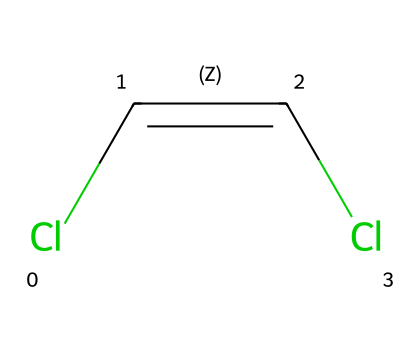What is the molecular formula of this compound? The molecular formula can be determined by counting the number of each type of atom in the structure. Here, there are 2 carbon (C) atoms, 2 chlorine (Cl) atoms, and 2 hydrogen (H) atoms connected in a particular arrangement. Thus, the molecular formula is C2H2Cl2.
Answer: C2H2Cl2 How many double bonds are present in this molecule? The structure shows a double bond between the two carbon atoms as indicated by the 'C=C' part in the SMILES notation. Therefore, there is one double bond present.
Answer: 1 What type of isomerism does dichloroethene exhibit? Dichloroethene exhibits geometric isomerism because it has the same molecular formula but a different spatial arrangement of atoms due to the restricted rotation around the double bond. This leads to cis and trans isomers.
Answer: geometric isomerism How many geometric isomers can dichloroethene form? The presence of two chlorine atoms attached to the carbon atoms in dichloroethene allows for the formation of two distinct configurations (cis and trans). Therefore, it can form two geometric isomers.
Answer: 2 What configuration does the 'C=C' indicate in this compound? The 'C=C' indicates a cis or trans configuration, which is determined by the positions of the substituents around the double bond. This signifies that the structure can be classified as either a cis isomer (similar groups on the same side) or a trans isomer (similar groups on opposite sides).
Answer: cis or trans Which atoms are involved in the double bond? The double bond is present between the carbon atoms, which can be observed from the structure's connectivity. Hence, the atoms involved in the double bond are the carbon atoms.
Answer: carbon atoms 